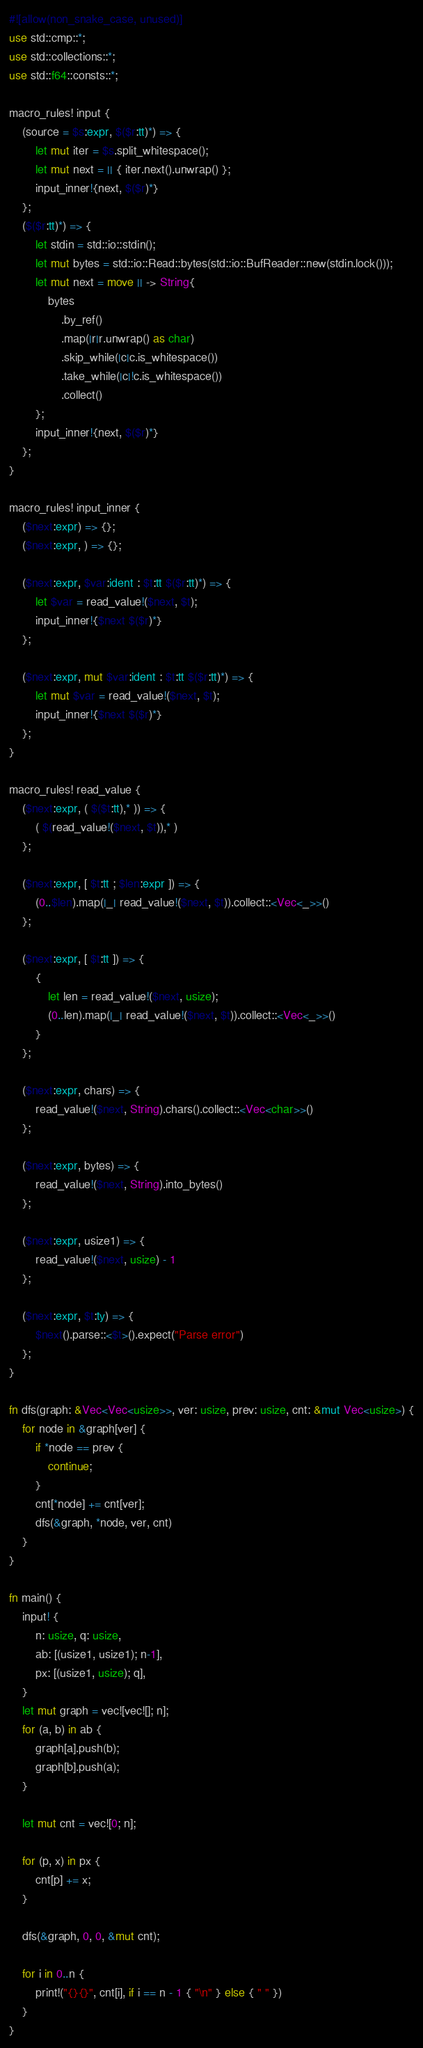Convert code to text. <code><loc_0><loc_0><loc_500><loc_500><_Rust_>#![allow(non_snake_case, unused)]
use std::cmp::*;
use std::collections::*;
use std::f64::consts::*;

macro_rules! input {
    (source = $s:expr, $($r:tt)*) => {
        let mut iter = $s.split_whitespace();
        let mut next = || { iter.next().unwrap() };
        input_inner!{next, $($r)*}
    };
    ($($r:tt)*) => {
        let stdin = std::io::stdin();
        let mut bytes = std::io::Read::bytes(std::io::BufReader::new(stdin.lock()));
        let mut next = move || -> String{
            bytes
                .by_ref()
                .map(|r|r.unwrap() as char)
                .skip_while(|c|c.is_whitespace())
                .take_while(|c|!c.is_whitespace())
                .collect()
        };
        input_inner!{next, $($r)*}
    };
}

macro_rules! input_inner {
    ($next:expr) => {};
    ($next:expr, ) => {};

    ($next:expr, $var:ident : $t:tt $($r:tt)*) => {
        let $var = read_value!($next, $t);
        input_inner!{$next $($r)*}
    };

    ($next:expr, mut $var:ident : $t:tt $($r:tt)*) => {
        let mut $var = read_value!($next, $t);
        input_inner!{$next $($r)*}
    };
}

macro_rules! read_value {
    ($next:expr, ( $($t:tt),* )) => {
        ( $(read_value!($next, $t)),* )
    };

    ($next:expr, [ $t:tt ; $len:expr ]) => {
        (0..$len).map(|_| read_value!($next, $t)).collect::<Vec<_>>()
    };

    ($next:expr, [ $t:tt ]) => {
        {
            let len = read_value!($next, usize);
            (0..len).map(|_| read_value!($next, $t)).collect::<Vec<_>>()
        }
    };

    ($next:expr, chars) => {
        read_value!($next, String).chars().collect::<Vec<char>>()
    };

    ($next:expr, bytes) => {
        read_value!($next, String).into_bytes()
    };

    ($next:expr, usize1) => {
        read_value!($next, usize) - 1
    };

    ($next:expr, $t:ty) => {
        $next().parse::<$t>().expect("Parse error")
    };
}

fn dfs(graph: &Vec<Vec<usize>>, ver: usize, prev: usize, cnt: &mut Vec<usize>) {
    for node in &graph[ver] {
        if *node == prev {
            continue;
        }
        cnt[*node] += cnt[ver];
        dfs(&graph, *node, ver, cnt)
    }
}

fn main() {
    input! {
        n: usize, q: usize,
        ab: [(usize1, usize1); n-1],
        px: [(usize1, usize); q],
    }
    let mut graph = vec![vec![]; n];
    for (a, b) in ab {
        graph[a].push(b);
        graph[b].push(a);
    }

    let mut cnt = vec![0; n];

    for (p, x) in px {
        cnt[p] += x;
    }

    dfs(&graph, 0, 0, &mut cnt);

    for i in 0..n {
        print!("{}{}", cnt[i], if i == n - 1 { "\n" } else { " " })
    }
}
</code> 